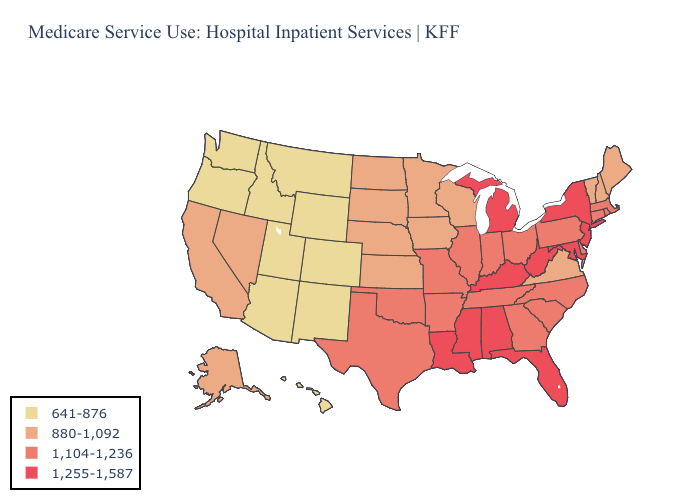Which states hav the highest value in the Northeast?
Keep it brief. New Jersey, New York. What is the value of Kansas?
Quick response, please. 880-1,092. Name the states that have a value in the range 1,104-1,236?
Answer briefly. Arkansas, Connecticut, Delaware, Georgia, Illinois, Indiana, Massachusetts, Missouri, North Carolina, Ohio, Oklahoma, Pennsylvania, Rhode Island, South Carolina, Tennessee, Texas. Does the map have missing data?
Concise answer only. No. Name the states that have a value in the range 880-1,092?
Write a very short answer. Alaska, California, Iowa, Kansas, Maine, Minnesota, Nebraska, Nevada, New Hampshire, North Dakota, South Dakota, Vermont, Virginia, Wisconsin. Among the states that border North Carolina , which have the highest value?
Write a very short answer. Georgia, South Carolina, Tennessee. Name the states that have a value in the range 1,255-1,587?
Give a very brief answer. Alabama, Florida, Kentucky, Louisiana, Maryland, Michigan, Mississippi, New Jersey, New York, West Virginia. Does Wisconsin have a higher value than Oregon?
Short answer required. Yes. Which states have the lowest value in the MidWest?
Answer briefly. Iowa, Kansas, Minnesota, Nebraska, North Dakota, South Dakota, Wisconsin. What is the lowest value in the USA?
Give a very brief answer. 641-876. What is the value of Arkansas?
Be succinct. 1,104-1,236. What is the highest value in the USA?
Write a very short answer. 1,255-1,587. Does South Dakota have the lowest value in the MidWest?
Quick response, please. Yes. Does the first symbol in the legend represent the smallest category?
Short answer required. Yes. What is the lowest value in the West?
Quick response, please. 641-876. 